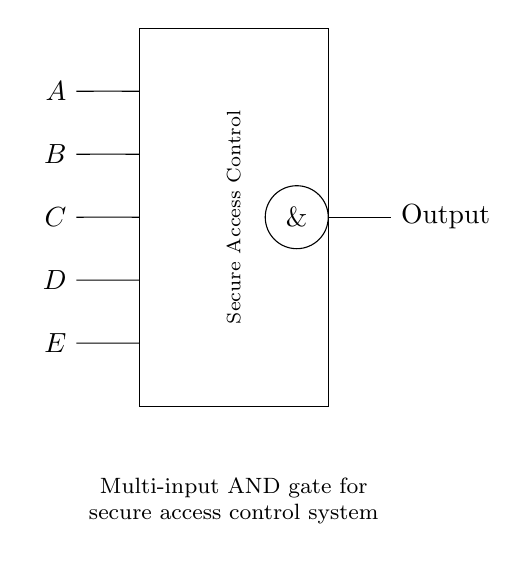What are the inputs to the AND gate? The inputs are labeled A, B, C, D, and E, which are drawn coming into the left side of the circuit in sequence from top to bottom.
Answer: A, B, C, D, E What type of logic gate is represented in the circuit? The circuit contains an AND gate, indicated by the symbol $\&$ inside a circle, confirming it's an AND gate rather than another type of logic gate.
Answer: AND gate How many inputs does the circuit have? The circuit has five distinct inputs (A, B, C, D, and E), which can be counted directly from the left side of the diagram where the inputs are clearly labeled.
Answer: Five What is the purpose of the AND gate in this circuit? The purpose of the AND gate, as stated in the explanatory text, is for secure access control, which implies that all inputs must be high for the output to be high, ensuring security.
Answer: Secure access control Which logical operation does this gate perform? The gate performs the logical multiplication (AND operation), meaning the output is true only when all inputs are true, which is fundamental to an AND gate operation.
Answer: Multiplication What is the output of the gate if all inputs are high? If all inputs A, B, C, D, and E are high (true), the output will also be high (true), which is characteristic of an AND gate, since it only outputs true when all inputs are true.
Answer: High 